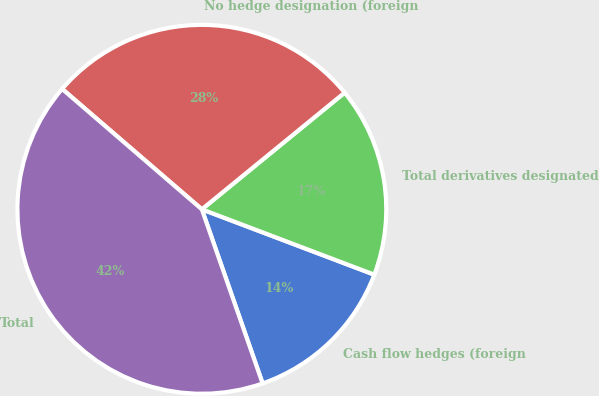<chart> <loc_0><loc_0><loc_500><loc_500><pie_chart><fcel>Cash flow hedges (foreign<fcel>Total derivatives designated<fcel>No hedge designation (foreign<fcel>Total<nl><fcel>13.89%<fcel>16.67%<fcel>27.78%<fcel>41.67%<nl></chart> 